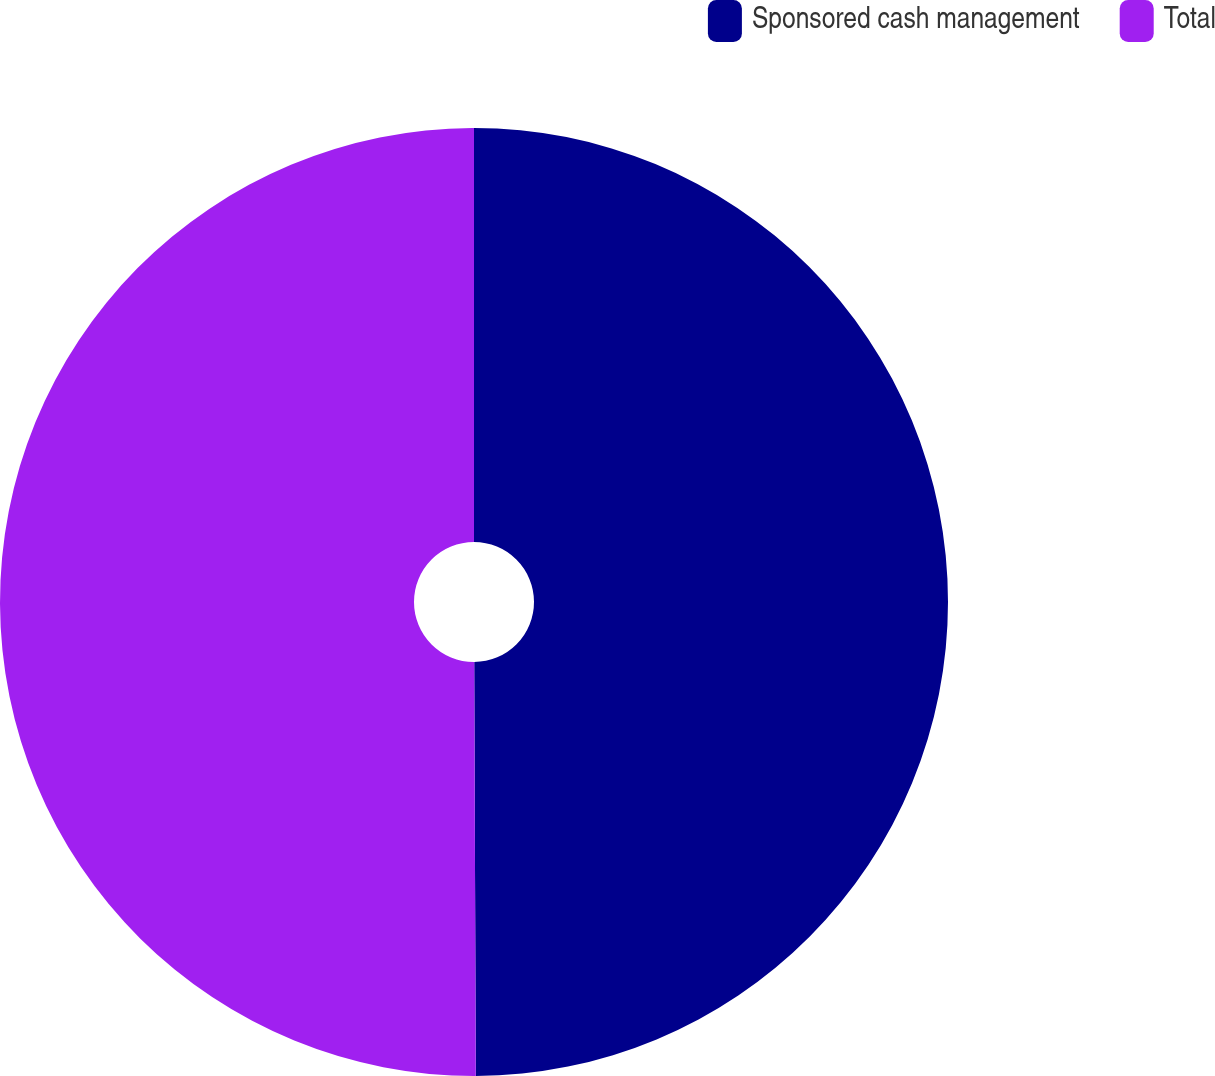<chart> <loc_0><loc_0><loc_500><loc_500><pie_chart><fcel>Sponsored cash management<fcel>Total<nl><fcel>49.94%<fcel>50.06%<nl></chart> 